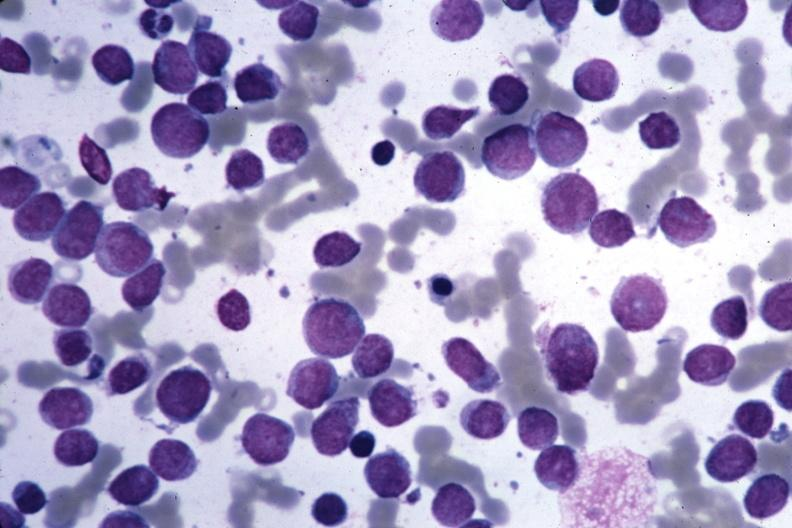s bone marrow present?
Answer the question using a single word or phrase. Yes 